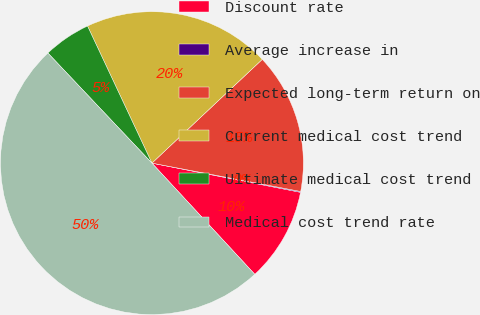Convert chart. <chart><loc_0><loc_0><loc_500><loc_500><pie_chart><fcel>Discount rate<fcel>Average increase in<fcel>Expected long-term return on<fcel>Current medical cost trend<fcel>Ultimate medical cost trend<fcel>Medical cost trend rate<nl><fcel>10.03%<fcel>0.09%<fcel>15.01%<fcel>19.98%<fcel>5.06%<fcel>49.83%<nl></chart> 